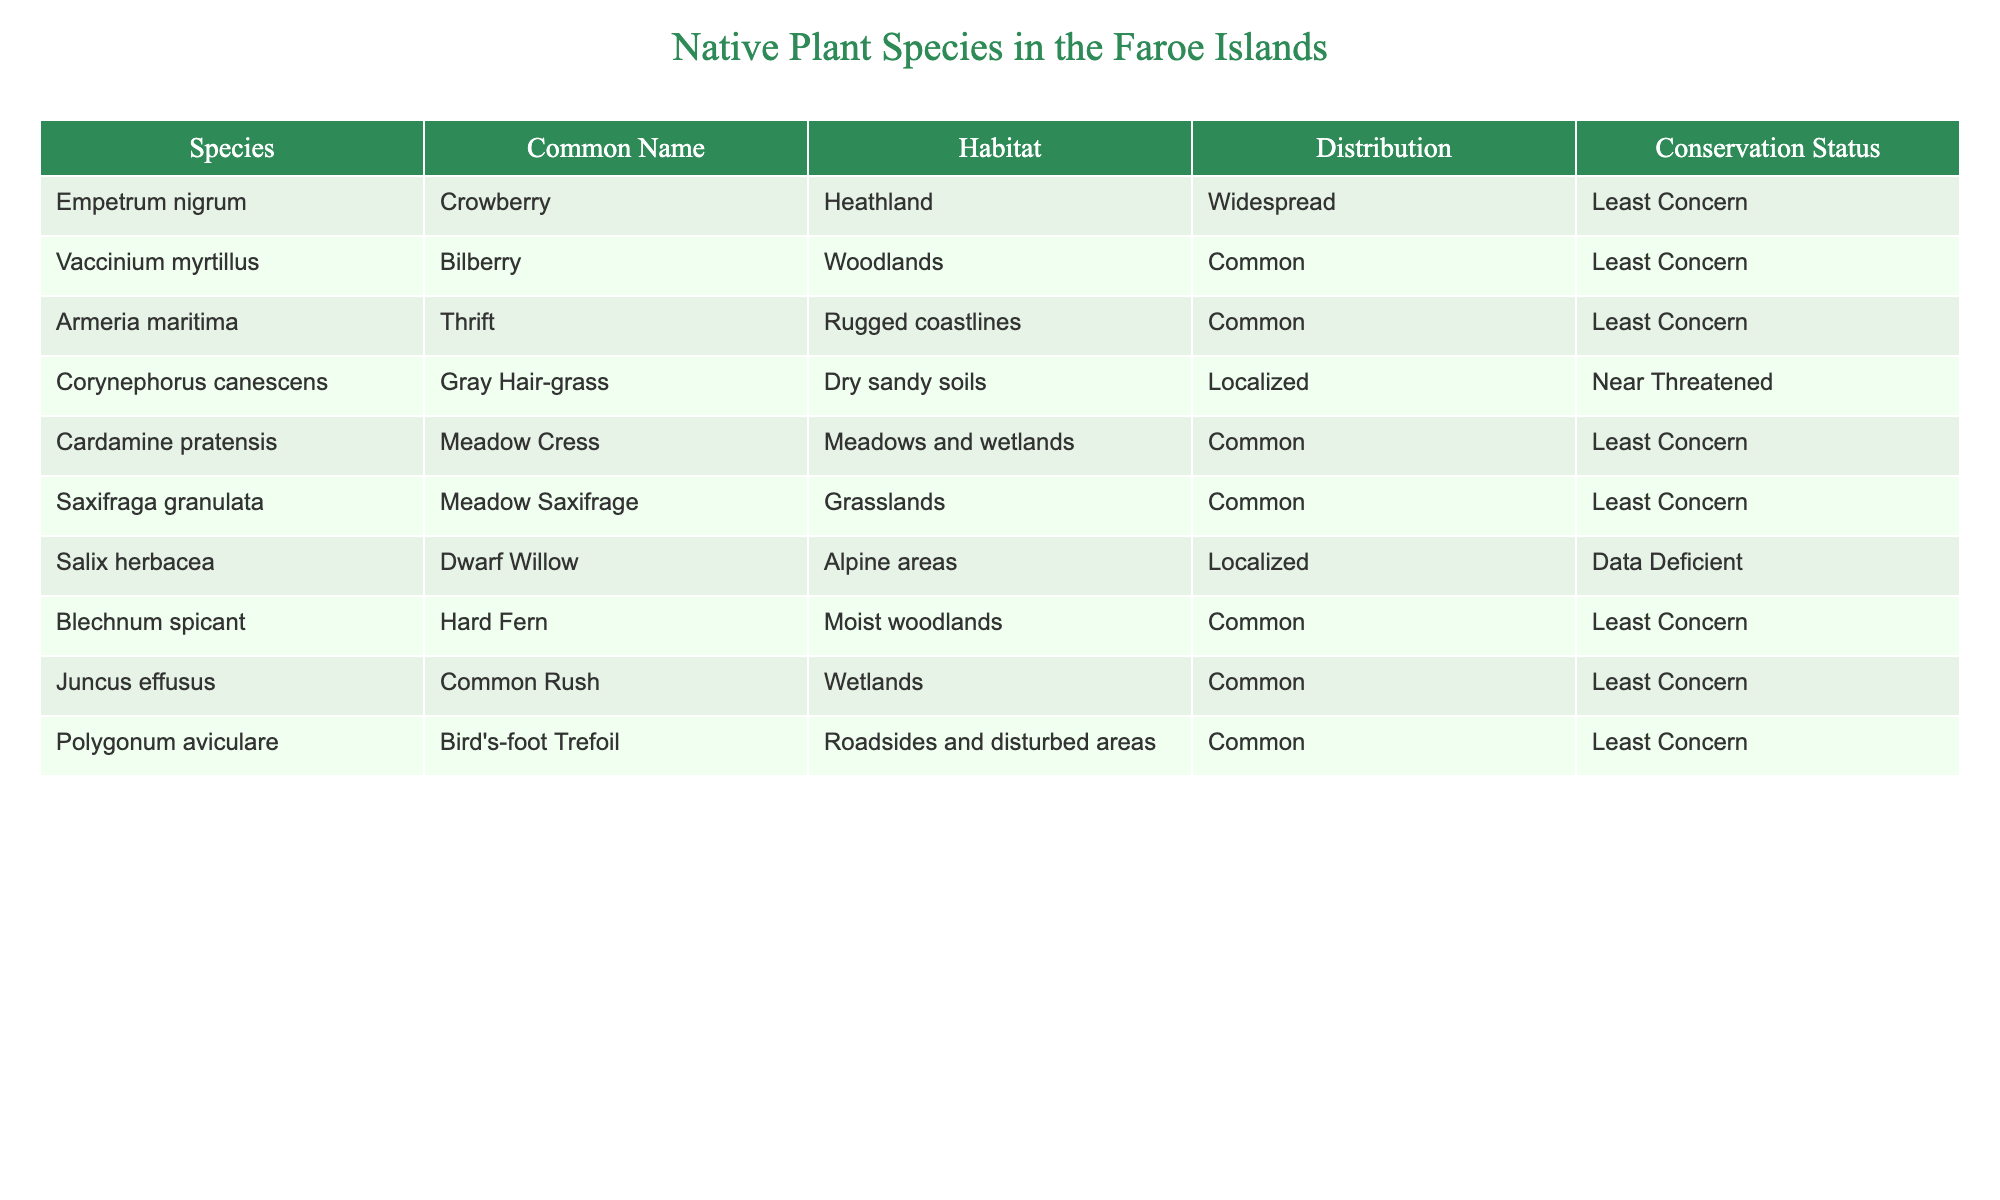What is the common name for Empetrum nigrum? The table indicates that Empetrum nigrum is commonly known as Crowberry.
Answer: Crowberry How many species in the table have a conservation status of "Least Concern"? By reviewing the conservation status column, we count the entries labeled as "Least Concern". There are 7 species with this status: Crowberry, Bilberry, Thrift, Meadow Cress, Meadow Saxifrage, Hard Fern, and Common Rush.
Answer: 7 Is Salix herbacea widely distributed in the Faroe Islands? The distribution column indicates that Salix herbacea is classified as "Localized", meaning it is not widely distributed.
Answer: No Which habitat supports the most species according to the table? We look at the habitat column and count the occurrences: Heathland has 1 species, Woodlands 1, Rugged coastlines 1, Dry sandy soils 1, Meadows and wetlands 1, Grasslands 1, Alpine areas 1, Moist woodlands 1, and Wetlands 1. Each habitat has only 1 species represented, indicating no habitat has a higher support in this dataset.
Answer: Each habitat has 1 species Which species is found in dry sandy soils, and what is its conservation status? From the table, Corynephorus canescens is noted as being found in dry sandy soils. Its conservation status is "Near Threatened".
Answer: Corynephorus canescens, Near Threatened How many species in the table are found in wetlands, and what are their names? The table shows that Juncus effusus is the only species listed under wetlands. Therefore, there is 1 species in this habitat, and it is called Common Rush.
Answer: 1, Common Rush Are all the native plant species in the Faroe Islands considered to be of "Data Deficient" status? A quick check reveals that only Salix herbacea holds the "Data Deficient" status, while the majority are "Least Concern". Thus, not all are of this status.
Answer: No What percentage of species listed is classified as "Localized"? There are 2 species classified as "Localized" (Corynephorus canescens and Salix herbacea) out of a total of 10 species. To find the percentage, the calculation would be (2/10) * 100 = 20%.
Answer: 20% 